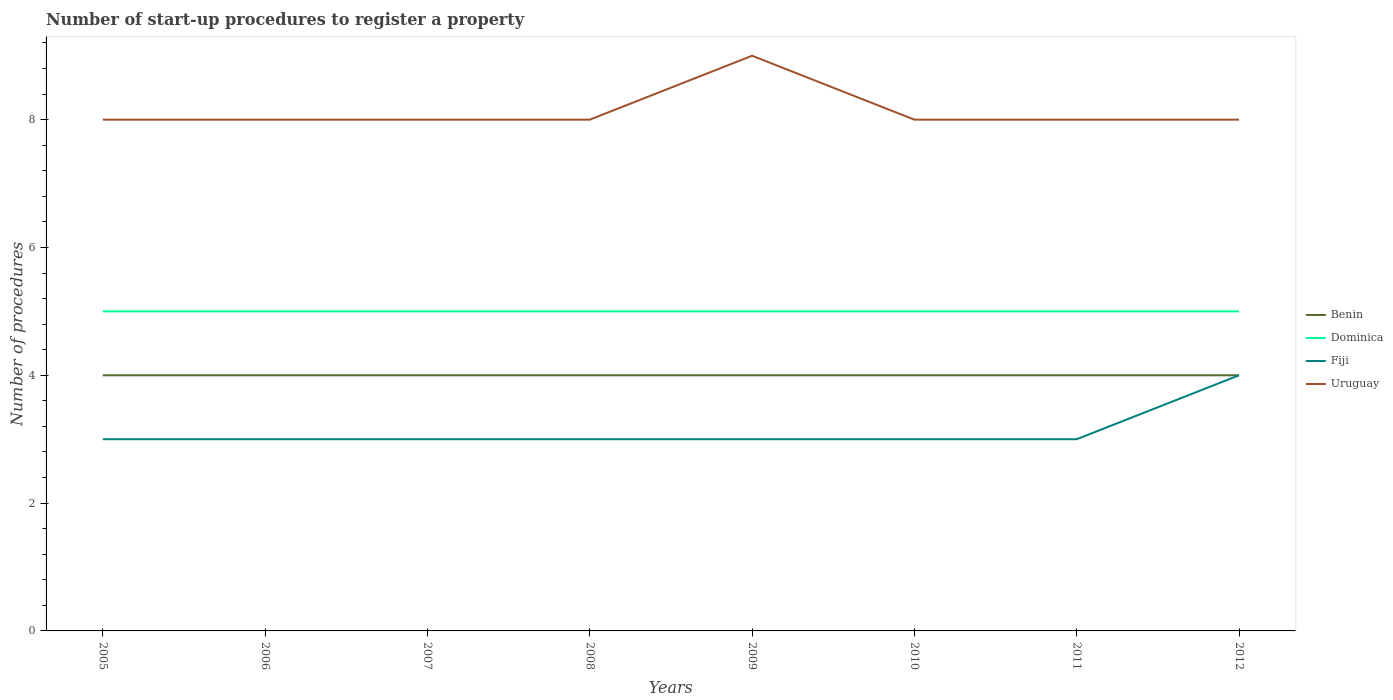Across all years, what is the maximum number of procedures required to register a property in Dominica?
Your answer should be compact. 5. What is the total number of procedures required to register a property in Uruguay in the graph?
Your answer should be very brief. -1. What is the difference between the highest and the second highest number of procedures required to register a property in Uruguay?
Give a very brief answer. 1. What is the difference between the highest and the lowest number of procedures required to register a property in Fiji?
Provide a succinct answer. 1. How many years are there in the graph?
Offer a very short reply. 8. What is the difference between two consecutive major ticks on the Y-axis?
Give a very brief answer. 2. Does the graph contain any zero values?
Your answer should be very brief. No. How are the legend labels stacked?
Provide a succinct answer. Vertical. What is the title of the graph?
Offer a very short reply. Number of start-up procedures to register a property. What is the label or title of the X-axis?
Provide a succinct answer. Years. What is the label or title of the Y-axis?
Your response must be concise. Number of procedures. What is the Number of procedures of Benin in 2005?
Your answer should be very brief. 4. What is the Number of procedures of Dominica in 2005?
Provide a short and direct response. 5. What is the Number of procedures in Benin in 2006?
Make the answer very short. 4. What is the Number of procedures in Fiji in 2006?
Provide a short and direct response. 3. What is the Number of procedures in Benin in 2007?
Your answer should be compact. 4. What is the Number of procedures in Fiji in 2007?
Offer a very short reply. 3. What is the Number of procedures of Uruguay in 2007?
Keep it short and to the point. 8. What is the Number of procedures in Benin in 2008?
Ensure brevity in your answer.  4. What is the Number of procedures of Dominica in 2008?
Ensure brevity in your answer.  5. What is the Number of procedures of Dominica in 2009?
Your response must be concise. 5. What is the Number of procedures of Uruguay in 2009?
Your response must be concise. 9. What is the Number of procedures of Benin in 2010?
Your answer should be compact. 4. What is the Number of procedures in Dominica in 2010?
Keep it short and to the point. 5. What is the Number of procedures of Uruguay in 2010?
Your answer should be compact. 8. What is the Number of procedures of Dominica in 2011?
Offer a terse response. 5. What is the Number of procedures in Uruguay in 2011?
Your response must be concise. 8. What is the Number of procedures in Benin in 2012?
Your response must be concise. 4. What is the Number of procedures in Dominica in 2012?
Ensure brevity in your answer.  5. What is the Number of procedures in Uruguay in 2012?
Offer a terse response. 8. Across all years, what is the maximum Number of procedures in Benin?
Provide a short and direct response. 4. Across all years, what is the maximum Number of procedures in Dominica?
Provide a succinct answer. 5. Across all years, what is the minimum Number of procedures of Fiji?
Ensure brevity in your answer.  3. Across all years, what is the minimum Number of procedures in Uruguay?
Offer a terse response. 8. What is the total Number of procedures in Benin in the graph?
Your answer should be compact. 32. What is the total Number of procedures of Fiji in the graph?
Offer a very short reply. 25. What is the total Number of procedures in Uruguay in the graph?
Your answer should be compact. 65. What is the difference between the Number of procedures of Benin in 2005 and that in 2007?
Provide a succinct answer. 0. What is the difference between the Number of procedures in Fiji in 2005 and that in 2008?
Your answer should be compact. 0. What is the difference between the Number of procedures in Fiji in 2005 and that in 2009?
Offer a terse response. 0. What is the difference between the Number of procedures of Benin in 2005 and that in 2010?
Your answer should be compact. 0. What is the difference between the Number of procedures of Dominica in 2005 and that in 2010?
Ensure brevity in your answer.  0. What is the difference between the Number of procedures in Fiji in 2005 and that in 2010?
Provide a short and direct response. 0. What is the difference between the Number of procedures of Uruguay in 2005 and that in 2010?
Make the answer very short. 0. What is the difference between the Number of procedures of Benin in 2005 and that in 2011?
Keep it short and to the point. 0. What is the difference between the Number of procedures in Dominica in 2005 and that in 2011?
Your response must be concise. 0. What is the difference between the Number of procedures of Uruguay in 2005 and that in 2011?
Your response must be concise. 0. What is the difference between the Number of procedures in Benin in 2005 and that in 2012?
Offer a very short reply. 0. What is the difference between the Number of procedures of Dominica in 2005 and that in 2012?
Your answer should be very brief. 0. What is the difference between the Number of procedures of Fiji in 2005 and that in 2012?
Keep it short and to the point. -1. What is the difference between the Number of procedures of Benin in 2006 and that in 2007?
Your response must be concise. 0. What is the difference between the Number of procedures of Dominica in 2006 and that in 2007?
Offer a terse response. 0. What is the difference between the Number of procedures in Uruguay in 2006 and that in 2007?
Offer a very short reply. 0. What is the difference between the Number of procedures in Dominica in 2006 and that in 2008?
Make the answer very short. 0. What is the difference between the Number of procedures in Dominica in 2006 and that in 2009?
Ensure brevity in your answer.  0. What is the difference between the Number of procedures of Fiji in 2006 and that in 2009?
Your response must be concise. 0. What is the difference between the Number of procedures of Benin in 2006 and that in 2010?
Provide a succinct answer. 0. What is the difference between the Number of procedures in Dominica in 2006 and that in 2010?
Keep it short and to the point. 0. What is the difference between the Number of procedures of Benin in 2006 and that in 2011?
Provide a succinct answer. 0. What is the difference between the Number of procedures in Dominica in 2006 and that in 2011?
Your answer should be very brief. 0. What is the difference between the Number of procedures in Benin in 2006 and that in 2012?
Your response must be concise. 0. What is the difference between the Number of procedures of Dominica in 2006 and that in 2012?
Your response must be concise. 0. What is the difference between the Number of procedures of Dominica in 2007 and that in 2008?
Your response must be concise. 0. What is the difference between the Number of procedures of Uruguay in 2007 and that in 2008?
Offer a terse response. 0. What is the difference between the Number of procedures of Benin in 2007 and that in 2009?
Your response must be concise. 0. What is the difference between the Number of procedures in Dominica in 2007 and that in 2011?
Keep it short and to the point. 0. What is the difference between the Number of procedures of Fiji in 2007 and that in 2011?
Give a very brief answer. 0. What is the difference between the Number of procedures of Uruguay in 2007 and that in 2011?
Your answer should be very brief. 0. What is the difference between the Number of procedures of Dominica in 2007 and that in 2012?
Provide a succinct answer. 0. What is the difference between the Number of procedures of Fiji in 2007 and that in 2012?
Your response must be concise. -1. What is the difference between the Number of procedures of Uruguay in 2007 and that in 2012?
Your response must be concise. 0. What is the difference between the Number of procedures in Benin in 2008 and that in 2009?
Your answer should be very brief. 0. What is the difference between the Number of procedures in Uruguay in 2008 and that in 2009?
Make the answer very short. -1. What is the difference between the Number of procedures of Dominica in 2008 and that in 2010?
Your response must be concise. 0. What is the difference between the Number of procedures in Uruguay in 2008 and that in 2010?
Keep it short and to the point. 0. What is the difference between the Number of procedures in Fiji in 2008 and that in 2011?
Keep it short and to the point. 0. What is the difference between the Number of procedures in Uruguay in 2008 and that in 2011?
Your answer should be very brief. 0. What is the difference between the Number of procedures of Fiji in 2008 and that in 2012?
Provide a succinct answer. -1. What is the difference between the Number of procedures in Benin in 2009 and that in 2010?
Your response must be concise. 0. What is the difference between the Number of procedures of Dominica in 2009 and that in 2010?
Make the answer very short. 0. What is the difference between the Number of procedures in Uruguay in 2009 and that in 2010?
Make the answer very short. 1. What is the difference between the Number of procedures in Benin in 2009 and that in 2012?
Your answer should be compact. 0. What is the difference between the Number of procedures of Fiji in 2009 and that in 2012?
Offer a very short reply. -1. What is the difference between the Number of procedures in Dominica in 2010 and that in 2011?
Provide a short and direct response. 0. What is the difference between the Number of procedures in Fiji in 2010 and that in 2011?
Your answer should be compact. 0. What is the difference between the Number of procedures of Benin in 2010 and that in 2012?
Give a very brief answer. 0. What is the difference between the Number of procedures of Dominica in 2010 and that in 2012?
Offer a terse response. 0. What is the difference between the Number of procedures in Benin in 2011 and that in 2012?
Offer a very short reply. 0. What is the difference between the Number of procedures in Fiji in 2011 and that in 2012?
Ensure brevity in your answer.  -1. What is the difference between the Number of procedures of Benin in 2005 and the Number of procedures of Fiji in 2006?
Make the answer very short. 1. What is the difference between the Number of procedures of Benin in 2005 and the Number of procedures of Uruguay in 2006?
Give a very brief answer. -4. What is the difference between the Number of procedures of Dominica in 2005 and the Number of procedures of Fiji in 2006?
Provide a succinct answer. 2. What is the difference between the Number of procedures of Dominica in 2005 and the Number of procedures of Uruguay in 2006?
Provide a succinct answer. -3. What is the difference between the Number of procedures in Fiji in 2005 and the Number of procedures in Uruguay in 2006?
Provide a short and direct response. -5. What is the difference between the Number of procedures in Benin in 2005 and the Number of procedures in Dominica in 2007?
Provide a short and direct response. -1. What is the difference between the Number of procedures in Benin in 2005 and the Number of procedures in Fiji in 2007?
Provide a short and direct response. 1. What is the difference between the Number of procedures of Dominica in 2005 and the Number of procedures of Uruguay in 2007?
Provide a succinct answer. -3. What is the difference between the Number of procedures in Fiji in 2005 and the Number of procedures in Uruguay in 2007?
Provide a short and direct response. -5. What is the difference between the Number of procedures of Dominica in 2005 and the Number of procedures of Fiji in 2008?
Give a very brief answer. 2. What is the difference between the Number of procedures of Dominica in 2005 and the Number of procedures of Uruguay in 2008?
Provide a short and direct response. -3. What is the difference between the Number of procedures in Benin in 2005 and the Number of procedures in Dominica in 2009?
Ensure brevity in your answer.  -1. What is the difference between the Number of procedures of Benin in 2005 and the Number of procedures of Fiji in 2009?
Provide a short and direct response. 1. What is the difference between the Number of procedures of Benin in 2005 and the Number of procedures of Uruguay in 2009?
Your response must be concise. -5. What is the difference between the Number of procedures of Dominica in 2005 and the Number of procedures of Fiji in 2009?
Offer a terse response. 2. What is the difference between the Number of procedures of Fiji in 2005 and the Number of procedures of Uruguay in 2009?
Keep it short and to the point. -6. What is the difference between the Number of procedures of Benin in 2005 and the Number of procedures of Fiji in 2010?
Make the answer very short. 1. What is the difference between the Number of procedures in Dominica in 2005 and the Number of procedures in Fiji in 2010?
Offer a very short reply. 2. What is the difference between the Number of procedures in Dominica in 2005 and the Number of procedures in Uruguay in 2010?
Offer a terse response. -3. What is the difference between the Number of procedures of Benin in 2005 and the Number of procedures of Dominica in 2011?
Give a very brief answer. -1. What is the difference between the Number of procedures of Benin in 2005 and the Number of procedures of Uruguay in 2011?
Keep it short and to the point. -4. What is the difference between the Number of procedures of Dominica in 2005 and the Number of procedures of Fiji in 2011?
Ensure brevity in your answer.  2. What is the difference between the Number of procedures of Benin in 2005 and the Number of procedures of Dominica in 2012?
Your answer should be compact. -1. What is the difference between the Number of procedures of Benin in 2005 and the Number of procedures of Fiji in 2012?
Your answer should be compact. 0. What is the difference between the Number of procedures in Fiji in 2005 and the Number of procedures in Uruguay in 2012?
Provide a short and direct response. -5. What is the difference between the Number of procedures of Dominica in 2006 and the Number of procedures of Uruguay in 2007?
Keep it short and to the point. -3. What is the difference between the Number of procedures in Benin in 2006 and the Number of procedures in Dominica in 2008?
Your answer should be compact. -1. What is the difference between the Number of procedures of Benin in 2006 and the Number of procedures of Uruguay in 2008?
Offer a terse response. -4. What is the difference between the Number of procedures of Dominica in 2006 and the Number of procedures of Fiji in 2008?
Offer a very short reply. 2. What is the difference between the Number of procedures in Dominica in 2006 and the Number of procedures in Uruguay in 2008?
Your answer should be very brief. -3. What is the difference between the Number of procedures of Fiji in 2006 and the Number of procedures of Uruguay in 2008?
Your answer should be compact. -5. What is the difference between the Number of procedures in Dominica in 2006 and the Number of procedures in Fiji in 2009?
Ensure brevity in your answer.  2. What is the difference between the Number of procedures of Dominica in 2006 and the Number of procedures of Uruguay in 2009?
Make the answer very short. -4. What is the difference between the Number of procedures of Fiji in 2006 and the Number of procedures of Uruguay in 2009?
Make the answer very short. -6. What is the difference between the Number of procedures in Benin in 2006 and the Number of procedures in Dominica in 2010?
Provide a succinct answer. -1. What is the difference between the Number of procedures of Benin in 2006 and the Number of procedures of Fiji in 2010?
Provide a short and direct response. 1. What is the difference between the Number of procedures in Benin in 2006 and the Number of procedures in Uruguay in 2010?
Provide a short and direct response. -4. What is the difference between the Number of procedures in Dominica in 2006 and the Number of procedures in Fiji in 2010?
Keep it short and to the point. 2. What is the difference between the Number of procedures in Benin in 2006 and the Number of procedures in Fiji in 2011?
Give a very brief answer. 1. What is the difference between the Number of procedures in Benin in 2006 and the Number of procedures in Fiji in 2012?
Your answer should be very brief. 0. What is the difference between the Number of procedures of Benin in 2006 and the Number of procedures of Uruguay in 2012?
Offer a very short reply. -4. What is the difference between the Number of procedures of Dominica in 2006 and the Number of procedures of Uruguay in 2012?
Provide a succinct answer. -3. What is the difference between the Number of procedures of Benin in 2007 and the Number of procedures of Fiji in 2008?
Your answer should be very brief. 1. What is the difference between the Number of procedures of Benin in 2007 and the Number of procedures of Uruguay in 2008?
Keep it short and to the point. -4. What is the difference between the Number of procedures in Dominica in 2007 and the Number of procedures in Fiji in 2008?
Keep it short and to the point. 2. What is the difference between the Number of procedures in Benin in 2007 and the Number of procedures in Uruguay in 2009?
Provide a short and direct response. -5. What is the difference between the Number of procedures in Dominica in 2007 and the Number of procedures in Fiji in 2009?
Keep it short and to the point. 2. What is the difference between the Number of procedures of Fiji in 2007 and the Number of procedures of Uruguay in 2009?
Your answer should be very brief. -6. What is the difference between the Number of procedures in Benin in 2007 and the Number of procedures in Dominica in 2010?
Your answer should be very brief. -1. What is the difference between the Number of procedures in Dominica in 2007 and the Number of procedures in Fiji in 2010?
Your answer should be very brief. 2. What is the difference between the Number of procedures of Dominica in 2007 and the Number of procedures of Uruguay in 2010?
Give a very brief answer. -3. What is the difference between the Number of procedures of Benin in 2007 and the Number of procedures of Uruguay in 2011?
Offer a terse response. -4. What is the difference between the Number of procedures of Dominica in 2007 and the Number of procedures of Fiji in 2011?
Provide a succinct answer. 2. What is the difference between the Number of procedures of Benin in 2007 and the Number of procedures of Uruguay in 2012?
Your answer should be very brief. -4. What is the difference between the Number of procedures of Fiji in 2007 and the Number of procedures of Uruguay in 2012?
Provide a short and direct response. -5. What is the difference between the Number of procedures of Fiji in 2008 and the Number of procedures of Uruguay in 2009?
Give a very brief answer. -6. What is the difference between the Number of procedures in Benin in 2008 and the Number of procedures in Dominica in 2010?
Give a very brief answer. -1. What is the difference between the Number of procedures in Benin in 2008 and the Number of procedures in Dominica in 2011?
Your answer should be compact. -1. What is the difference between the Number of procedures in Benin in 2008 and the Number of procedures in Uruguay in 2011?
Ensure brevity in your answer.  -4. What is the difference between the Number of procedures in Dominica in 2008 and the Number of procedures in Fiji in 2011?
Offer a very short reply. 2. What is the difference between the Number of procedures of Benin in 2008 and the Number of procedures of Dominica in 2012?
Give a very brief answer. -1. What is the difference between the Number of procedures in Dominica in 2008 and the Number of procedures in Fiji in 2012?
Ensure brevity in your answer.  1. What is the difference between the Number of procedures of Dominica in 2008 and the Number of procedures of Uruguay in 2012?
Offer a very short reply. -3. What is the difference between the Number of procedures in Benin in 2009 and the Number of procedures in Dominica in 2010?
Your answer should be very brief. -1. What is the difference between the Number of procedures in Dominica in 2009 and the Number of procedures in Uruguay in 2010?
Your response must be concise. -3. What is the difference between the Number of procedures in Benin in 2009 and the Number of procedures in Dominica in 2011?
Provide a succinct answer. -1. What is the difference between the Number of procedures of Benin in 2009 and the Number of procedures of Uruguay in 2011?
Offer a terse response. -4. What is the difference between the Number of procedures of Dominica in 2009 and the Number of procedures of Fiji in 2011?
Offer a terse response. 2. What is the difference between the Number of procedures in Dominica in 2009 and the Number of procedures in Uruguay in 2011?
Offer a very short reply. -3. What is the difference between the Number of procedures in Benin in 2009 and the Number of procedures in Dominica in 2012?
Make the answer very short. -1. What is the difference between the Number of procedures of Dominica in 2009 and the Number of procedures of Fiji in 2012?
Keep it short and to the point. 1. What is the difference between the Number of procedures in Dominica in 2009 and the Number of procedures in Uruguay in 2012?
Your response must be concise. -3. What is the difference between the Number of procedures of Fiji in 2009 and the Number of procedures of Uruguay in 2012?
Your answer should be compact. -5. What is the difference between the Number of procedures of Benin in 2010 and the Number of procedures of Dominica in 2011?
Offer a very short reply. -1. What is the difference between the Number of procedures of Benin in 2010 and the Number of procedures of Uruguay in 2011?
Ensure brevity in your answer.  -4. What is the difference between the Number of procedures of Dominica in 2010 and the Number of procedures of Uruguay in 2011?
Provide a short and direct response. -3. What is the difference between the Number of procedures in Benin in 2010 and the Number of procedures in Dominica in 2012?
Provide a succinct answer. -1. What is the difference between the Number of procedures of Dominica in 2010 and the Number of procedures of Fiji in 2012?
Ensure brevity in your answer.  1. What is the difference between the Number of procedures in Dominica in 2010 and the Number of procedures in Uruguay in 2012?
Offer a very short reply. -3. What is the difference between the Number of procedures of Fiji in 2010 and the Number of procedures of Uruguay in 2012?
Ensure brevity in your answer.  -5. What is the difference between the Number of procedures in Benin in 2011 and the Number of procedures in Uruguay in 2012?
Provide a short and direct response. -4. What is the difference between the Number of procedures in Dominica in 2011 and the Number of procedures in Fiji in 2012?
Your answer should be compact. 1. What is the average Number of procedures in Fiji per year?
Provide a succinct answer. 3.12. What is the average Number of procedures in Uruguay per year?
Offer a terse response. 8.12. In the year 2006, what is the difference between the Number of procedures in Benin and Number of procedures in Fiji?
Provide a succinct answer. 1. In the year 2006, what is the difference between the Number of procedures of Dominica and Number of procedures of Fiji?
Your response must be concise. 2. In the year 2007, what is the difference between the Number of procedures in Dominica and Number of procedures in Fiji?
Your answer should be compact. 2. In the year 2008, what is the difference between the Number of procedures of Benin and Number of procedures of Dominica?
Your answer should be very brief. -1. In the year 2008, what is the difference between the Number of procedures in Benin and Number of procedures in Uruguay?
Your answer should be very brief. -4. In the year 2008, what is the difference between the Number of procedures of Dominica and Number of procedures of Fiji?
Provide a succinct answer. 2. In the year 2009, what is the difference between the Number of procedures in Benin and Number of procedures in Dominica?
Your response must be concise. -1. In the year 2009, what is the difference between the Number of procedures in Dominica and Number of procedures in Fiji?
Keep it short and to the point. 2. In the year 2009, what is the difference between the Number of procedures of Fiji and Number of procedures of Uruguay?
Keep it short and to the point. -6. In the year 2010, what is the difference between the Number of procedures in Benin and Number of procedures in Fiji?
Your answer should be compact. 1. In the year 2011, what is the difference between the Number of procedures in Benin and Number of procedures in Dominica?
Offer a very short reply. -1. In the year 2011, what is the difference between the Number of procedures in Fiji and Number of procedures in Uruguay?
Offer a very short reply. -5. In the year 2012, what is the difference between the Number of procedures of Benin and Number of procedures of Dominica?
Ensure brevity in your answer.  -1. In the year 2012, what is the difference between the Number of procedures of Benin and Number of procedures of Fiji?
Keep it short and to the point. 0. In the year 2012, what is the difference between the Number of procedures of Benin and Number of procedures of Uruguay?
Keep it short and to the point. -4. In the year 2012, what is the difference between the Number of procedures in Dominica and Number of procedures in Fiji?
Your answer should be compact. 1. In the year 2012, what is the difference between the Number of procedures of Fiji and Number of procedures of Uruguay?
Your answer should be very brief. -4. What is the ratio of the Number of procedures of Benin in 2005 to that in 2006?
Keep it short and to the point. 1. What is the ratio of the Number of procedures of Dominica in 2005 to that in 2006?
Make the answer very short. 1. What is the ratio of the Number of procedures in Fiji in 2005 to that in 2006?
Give a very brief answer. 1. What is the ratio of the Number of procedures of Uruguay in 2005 to that in 2006?
Keep it short and to the point. 1. What is the ratio of the Number of procedures of Uruguay in 2005 to that in 2007?
Give a very brief answer. 1. What is the ratio of the Number of procedures of Benin in 2005 to that in 2008?
Ensure brevity in your answer.  1. What is the ratio of the Number of procedures of Dominica in 2005 to that in 2009?
Make the answer very short. 1. What is the ratio of the Number of procedures in Uruguay in 2005 to that in 2009?
Make the answer very short. 0.89. What is the ratio of the Number of procedures of Fiji in 2005 to that in 2010?
Keep it short and to the point. 1. What is the ratio of the Number of procedures of Benin in 2005 to that in 2011?
Your answer should be compact. 1. What is the ratio of the Number of procedures of Fiji in 2005 to that in 2011?
Ensure brevity in your answer.  1. What is the ratio of the Number of procedures of Uruguay in 2005 to that in 2011?
Your answer should be compact. 1. What is the ratio of the Number of procedures of Benin in 2005 to that in 2012?
Provide a short and direct response. 1. What is the ratio of the Number of procedures in Fiji in 2005 to that in 2012?
Give a very brief answer. 0.75. What is the ratio of the Number of procedures of Benin in 2006 to that in 2008?
Your answer should be compact. 1. What is the ratio of the Number of procedures in Fiji in 2006 to that in 2008?
Offer a terse response. 1. What is the ratio of the Number of procedures of Uruguay in 2006 to that in 2008?
Offer a terse response. 1. What is the ratio of the Number of procedures in Dominica in 2006 to that in 2009?
Your answer should be compact. 1. What is the ratio of the Number of procedures of Dominica in 2006 to that in 2010?
Offer a very short reply. 1. What is the ratio of the Number of procedures of Uruguay in 2006 to that in 2010?
Ensure brevity in your answer.  1. What is the ratio of the Number of procedures in Benin in 2006 to that in 2011?
Provide a short and direct response. 1. What is the ratio of the Number of procedures in Fiji in 2006 to that in 2011?
Your answer should be very brief. 1. What is the ratio of the Number of procedures in Uruguay in 2006 to that in 2011?
Give a very brief answer. 1. What is the ratio of the Number of procedures of Fiji in 2006 to that in 2012?
Your answer should be compact. 0.75. What is the ratio of the Number of procedures in Uruguay in 2006 to that in 2012?
Keep it short and to the point. 1. What is the ratio of the Number of procedures in Dominica in 2007 to that in 2008?
Your answer should be compact. 1. What is the ratio of the Number of procedures in Benin in 2007 to that in 2009?
Provide a short and direct response. 1. What is the ratio of the Number of procedures in Dominica in 2007 to that in 2009?
Provide a short and direct response. 1. What is the ratio of the Number of procedures of Fiji in 2007 to that in 2009?
Offer a very short reply. 1. What is the ratio of the Number of procedures in Uruguay in 2007 to that in 2009?
Your answer should be very brief. 0.89. What is the ratio of the Number of procedures in Benin in 2007 to that in 2010?
Your answer should be very brief. 1. What is the ratio of the Number of procedures in Dominica in 2007 to that in 2010?
Your answer should be compact. 1. What is the ratio of the Number of procedures of Fiji in 2007 to that in 2011?
Ensure brevity in your answer.  1. What is the ratio of the Number of procedures of Fiji in 2007 to that in 2012?
Offer a terse response. 0.75. What is the ratio of the Number of procedures of Uruguay in 2007 to that in 2012?
Keep it short and to the point. 1. What is the ratio of the Number of procedures in Dominica in 2008 to that in 2009?
Your answer should be very brief. 1. What is the ratio of the Number of procedures in Fiji in 2008 to that in 2009?
Give a very brief answer. 1. What is the ratio of the Number of procedures of Dominica in 2008 to that in 2010?
Give a very brief answer. 1. What is the ratio of the Number of procedures in Uruguay in 2008 to that in 2010?
Ensure brevity in your answer.  1. What is the ratio of the Number of procedures of Dominica in 2008 to that in 2011?
Keep it short and to the point. 1. What is the ratio of the Number of procedures in Fiji in 2008 to that in 2011?
Your response must be concise. 1. What is the ratio of the Number of procedures of Benin in 2008 to that in 2012?
Provide a succinct answer. 1. What is the ratio of the Number of procedures of Uruguay in 2008 to that in 2012?
Provide a succinct answer. 1. What is the ratio of the Number of procedures of Fiji in 2009 to that in 2010?
Ensure brevity in your answer.  1. What is the ratio of the Number of procedures in Fiji in 2009 to that in 2011?
Keep it short and to the point. 1. What is the ratio of the Number of procedures of Benin in 2009 to that in 2012?
Make the answer very short. 1. What is the ratio of the Number of procedures in Fiji in 2009 to that in 2012?
Make the answer very short. 0.75. What is the ratio of the Number of procedures in Benin in 2010 to that in 2011?
Your answer should be very brief. 1. What is the ratio of the Number of procedures in Dominica in 2010 to that in 2011?
Your response must be concise. 1. What is the ratio of the Number of procedures of Uruguay in 2010 to that in 2011?
Your answer should be very brief. 1. What is the ratio of the Number of procedures of Benin in 2010 to that in 2012?
Keep it short and to the point. 1. What is the ratio of the Number of procedures in Benin in 2011 to that in 2012?
Your answer should be compact. 1. What is the ratio of the Number of procedures in Dominica in 2011 to that in 2012?
Your response must be concise. 1. What is the difference between the highest and the second highest Number of procedures in Fiji?
Offer a very short reply. 1. What is the difference between the highest and the second highest Number of procedures of Uruguay?
Your response must be concise. 1. What is the difference between the highest and the lowest Number of procedures in Dominica?
Offer a terse response. 0. 